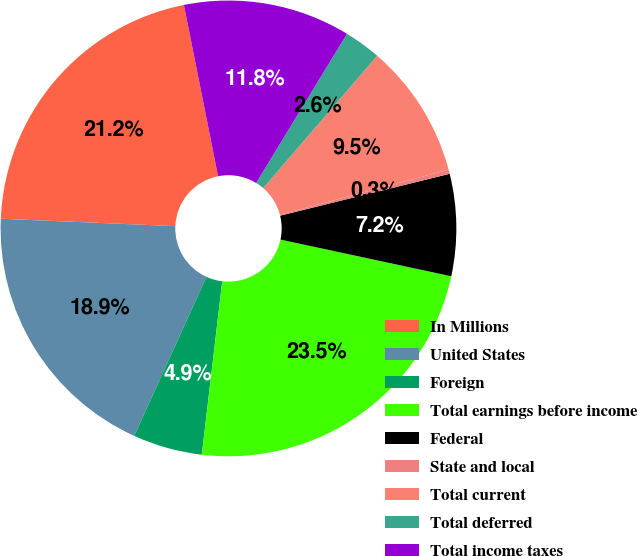Convert chart to OTSL. <chart><loc_0><loc_0><loc_500><loc_500><pie_chart><fcel>In Millions<fcel>United States<fcel>Foreign<fcel>Total earnings before income<fcel>Federal<fcel>State and local<fcel>Total current<fcel>Total deferred<fcel>Total income taxes<nl><fcel>21.19%<fcel>18.89%<fcel>4.92%<fcel>23.5%<fcel>7.22%<fcel>0.3%<fcel>9.53%<fcel>2.61%<fcel>11.84%<nl></chart> 